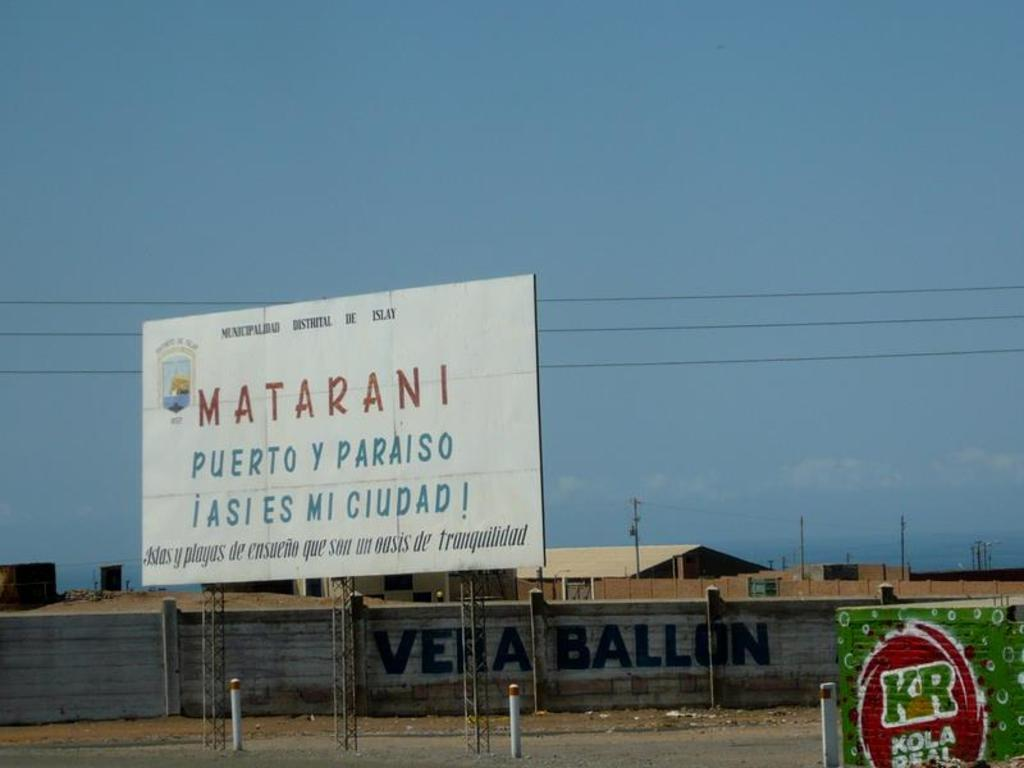<image>
Share a concise interpretation of the image provided. A sign for Matarani stands tall near a KR Kola Real sign 